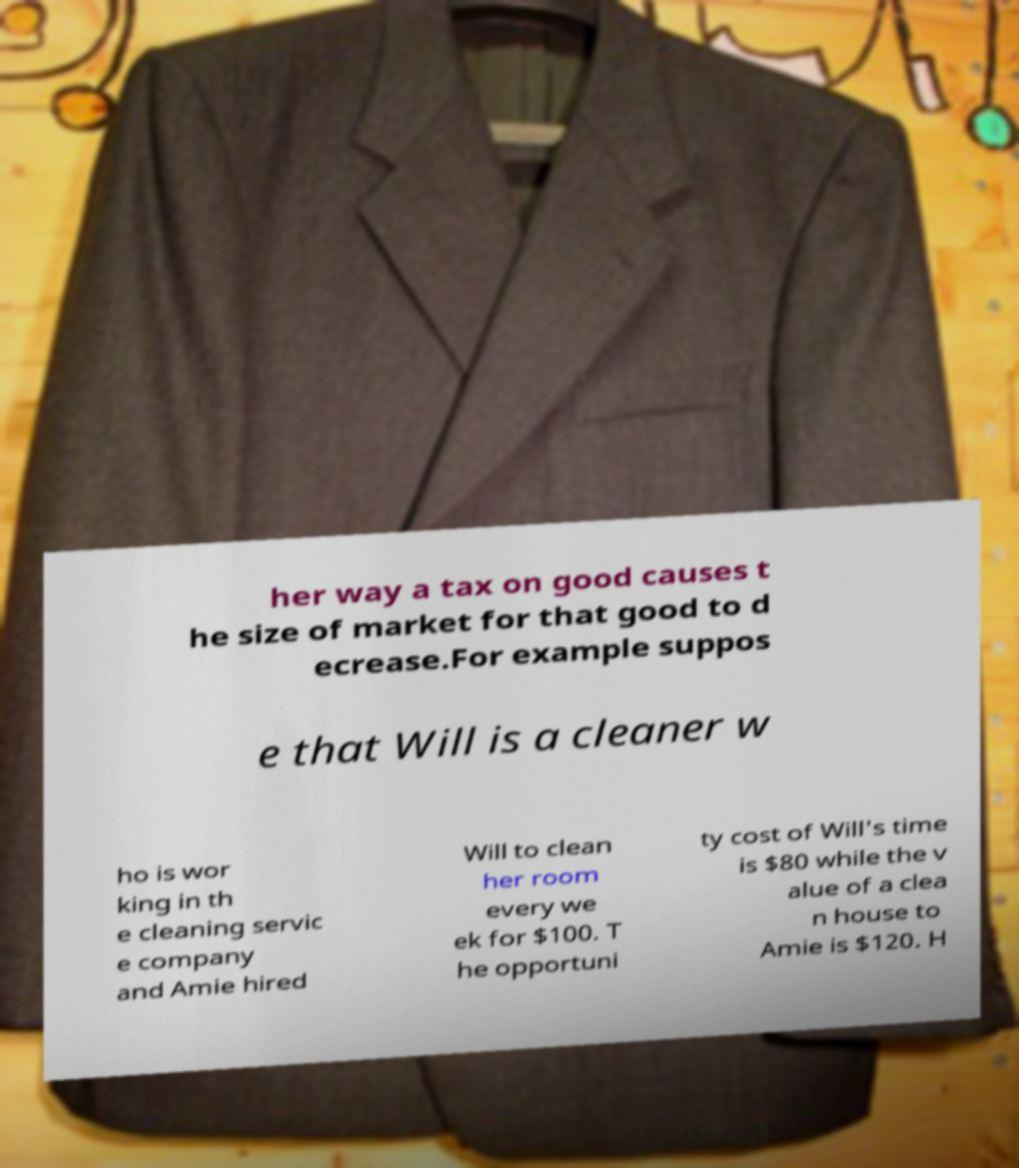Could you assist in decoding the text presented in this image and type it out clearly? her way a tax on good causes t he size of market for that good to d ecrease.For example suppos e that Will is a cleaner w ho is wor king in th e cleaning servic e company and Amie hired Will to clean her room every we ek for $100. T he opportuni ty cost of Will's time is $80 while the v alue of a clea n house to Amie is $120. H 